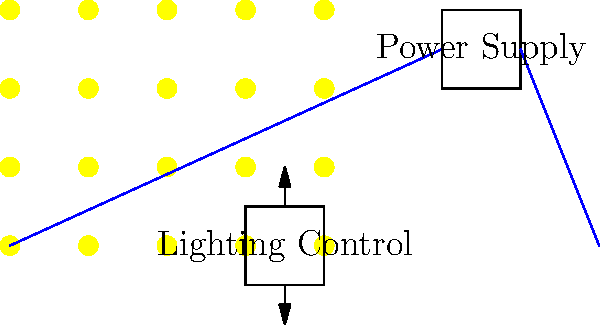As a director planning a women's health documentary, you need to design an energy-efficient lighting system for your film set using LED arrays. If each LED in the array consumes 0.5W and you need to achieve a total luminous flux of 10,000 lumens, with each LED producing 100 lumens, how many LEDs should be used in the array to minimize power consumption while meeting the lighting requirements? To solve this problem, we need to follow these steps:

1. Determine the number of LEDs required to achieve the desired luminous flux:
   - Total luminous flux needed = 10,000 lumens
   - Luminous flux per LED = 100 lumens
   - Number of LEDs = Total luminous flux / Luminous flux per LED
   - Number of LEDs = 10,000 / 100 = 100 LEDs

2. Calculate the power consumption of the LED array:
   - Power consumption per LED = 0.5W
   - Total power consumption = Number of LEDs × Power consumption per LED
   - Total power consumption = 100 × 0.5W = 50W

3. Verify if this setup meets the energy efficiency requirements:
   - The calculated setup uses the minimum number of LEDs to achieve the desired luminous flux, which inherently minimizes power consumption.
   - The power efficiency of this setup is:
     Efficiency = Total luminous flux / Total power consumption
     Efficiency = 10,000 lumens / 50W = 200 lumens/W

This efficiency is considered high for LED lighting systems, indicating that the design is energy-efficient.

Therefore, using 100 LEDs in the array will provide the required lighting while minimizing power consumption.
Answer: 100 LEDs 